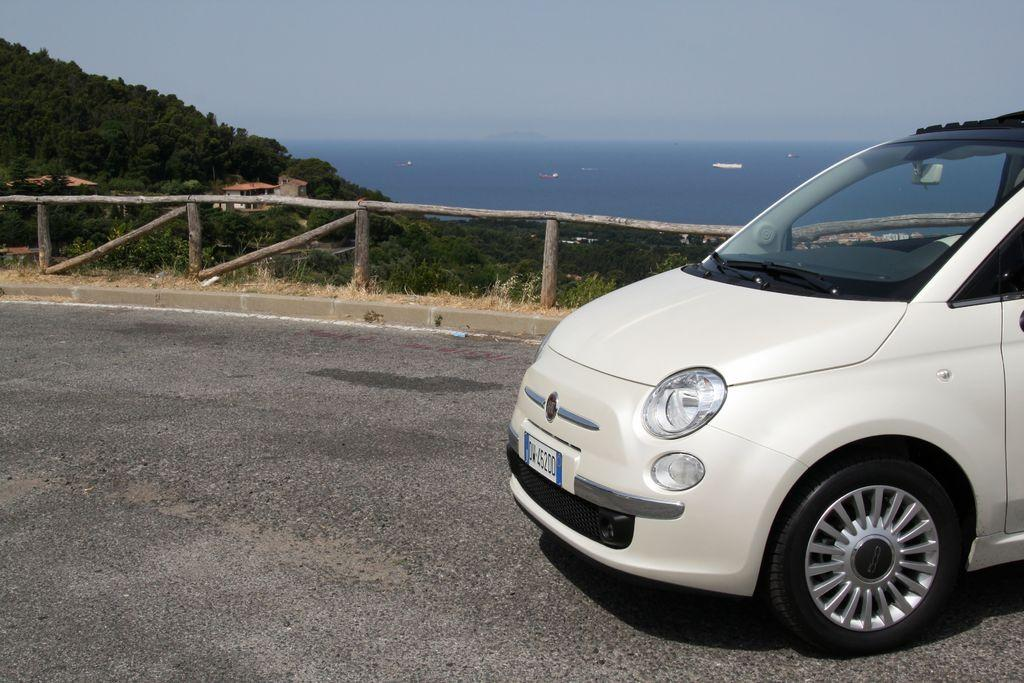What type of vehicle is on the road in the image? There is a white color car on the road in the image. What can be seen in the background of the image? There are trees and a building visible in the image. What is in the water in the image? There are boats in the water in the image. What is separating the road from the water in the image? There is a fence in the image. How would you describe the sky in the image? The sky is cloudy in the image. What type of fan is visible in the image? There is no fan present in the image. What view can be seen from the car in the image? The image does not provide a view from the car, as it is focused on the car itself and its surroundings. 